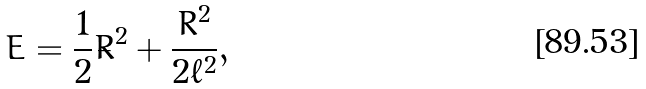<formula> <loc_0><loc_0><loc_500><loc_500>E = \frac { 1 } { 2 } \dot { R } ^ { 2 } + \frac { R ^ { 2 } } { 2 \ell ^ { 2 } } ,</formula> 